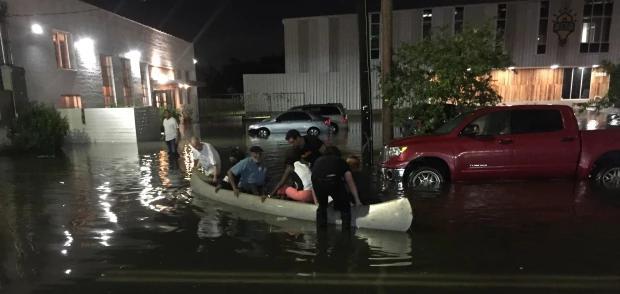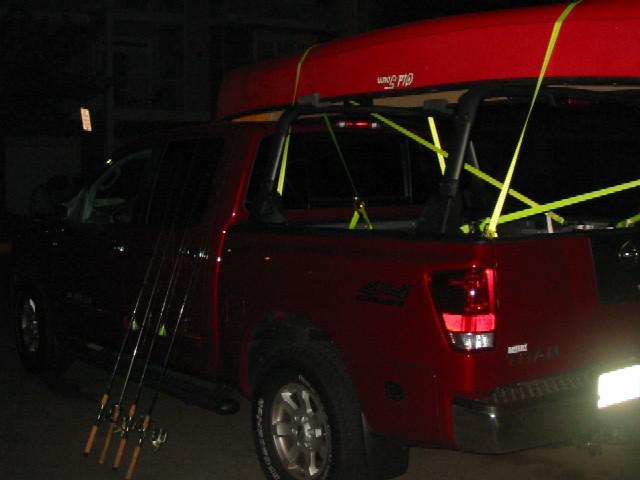The first image is the image on the left, the second image is the image on the right. Assess this claim about the two images: "In the right image there is a truck driving to the left in the daytime.". Correct or not? Answer yes or no. No. 